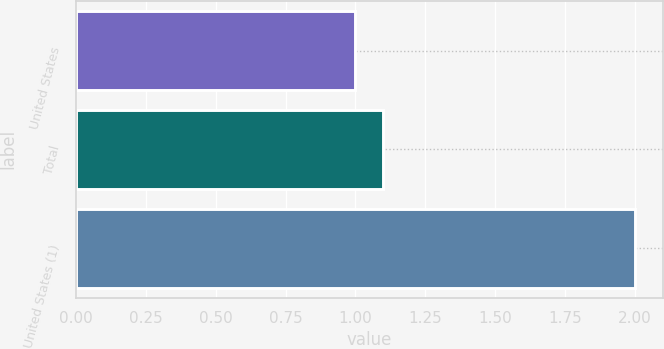Convert chart. <chart><loc_0><loc_0><loc_500><loc_500><bar_chart><fcel>United States<fcel>Total<fcel>United States (1)<nl><fcel>1<fcel>1.1<fcel>2<nl></chart> 